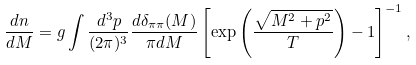Convert formula to latex. <formula><loc_0><loc_0><loc_500><loc_500>\frac { d n } { d M } = g \int \frac { d ^ { 3 } p } { ( 2 \pi ) ^ { 3 } } \frac { d { \delta _ { \pi \pi } ( M ) } } { \pi d M } \left [ \exp \left ( \frac { \sqrt { M ^ { 2 } + { p } ^ { 2 } } } { T } \right ) - 1 \right ] ^ { - 1 } ,</formula> 